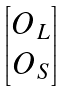Convert formula to latex. <formula><loc_0><loc_0><loc_500><loc_500>\begin{bmatrix} O _ { L } \\ O _ { S } \end{bmatrix}</formula> 